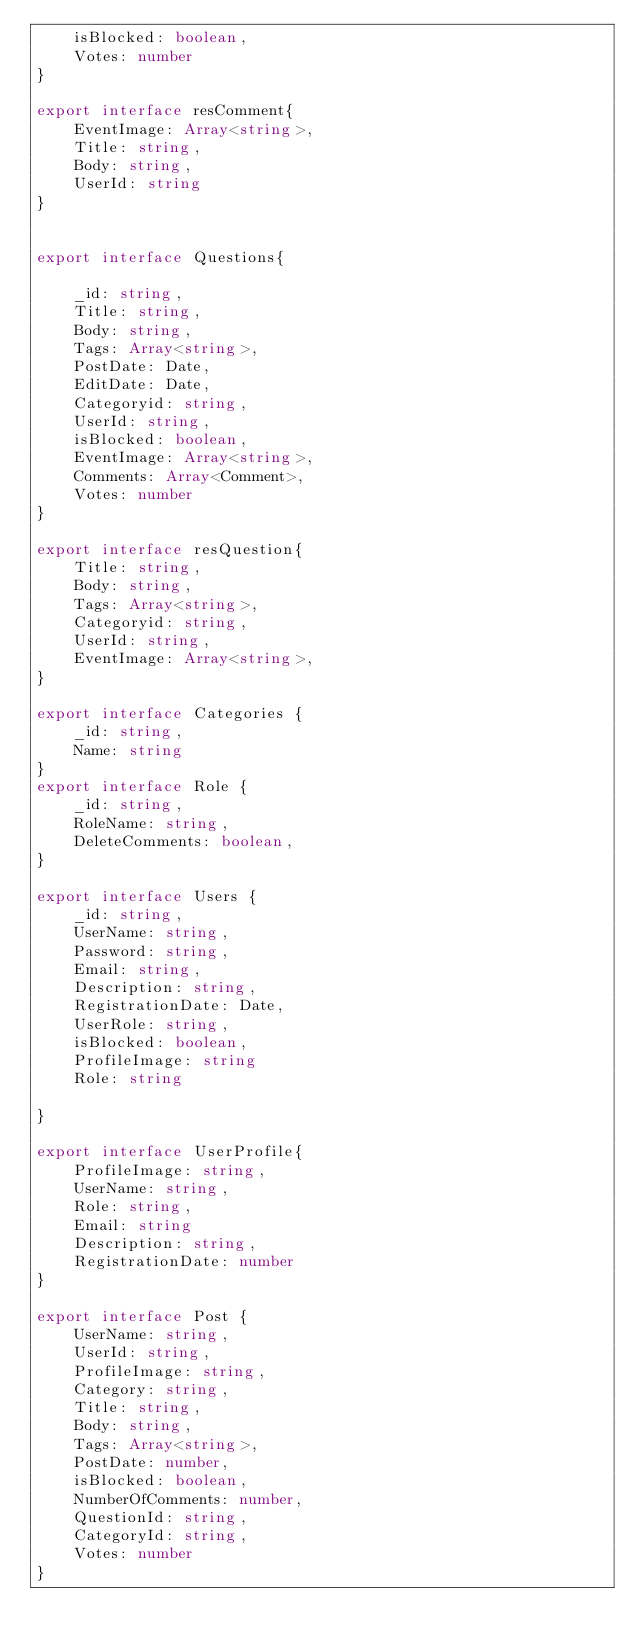Convert code to text. <code><loc_0><loc_0><loc_500><loc_500><_TypeScript_>    isBlocked: boolean,
    Votes: number
}

export interface resComment{ 
    EventImage: Array<string>,
    Title: string,
    Body: string,
    UserId: string
}


export interface Questions{
   
    _id: string,
    Title: string,
    Body: string,
    Tags: Array<string>,
    PostDate: Date,
    EditDate: Date,
    Categoryid: string,
    UserId: string,
    isBlocked: boolean,
    EventImage: Array<string>,
    Comments: Array<Comment>,
    Votes: number
}

export interface resQuestion{
    Title: string,
    Body: string,
    Tags: Array<string>,
    Categoryid: string,
    UserId: string,
    EventImage: Array<string>,
}

export interface Categories {
    _id: string,
    Name: string
}
export interface Role {
    _id: string,
    RoleName: string,
    DeleteComments: boolean,
}

export interface Users {
    _id: string,
    UserName: string,
    Password: string,
    Email: string,
    Description: string,
    RegistrationDate: Date,
    UserRole: string,
    isBlocked: boolean,
    ProfileImage: string
    Role: string

}

export interface UserProfile{
    ProfileImage: string,
    UserName: string,
    Role: string,
    Email: string
    Description: string,
    RegistrationDate: number
}

export interface Post {
    UserName: string,
    UserId: string,
    ProfileImage: string,
    Category: string,
    Title: string,
    Body: string,
    Tags: Array<string>,
    PostDate: number,
    isBlocked: boolean,
    NumberOfComments: number,
    QuestionId: string,
    CategoryId: string,
    Votes: number
}</code> 